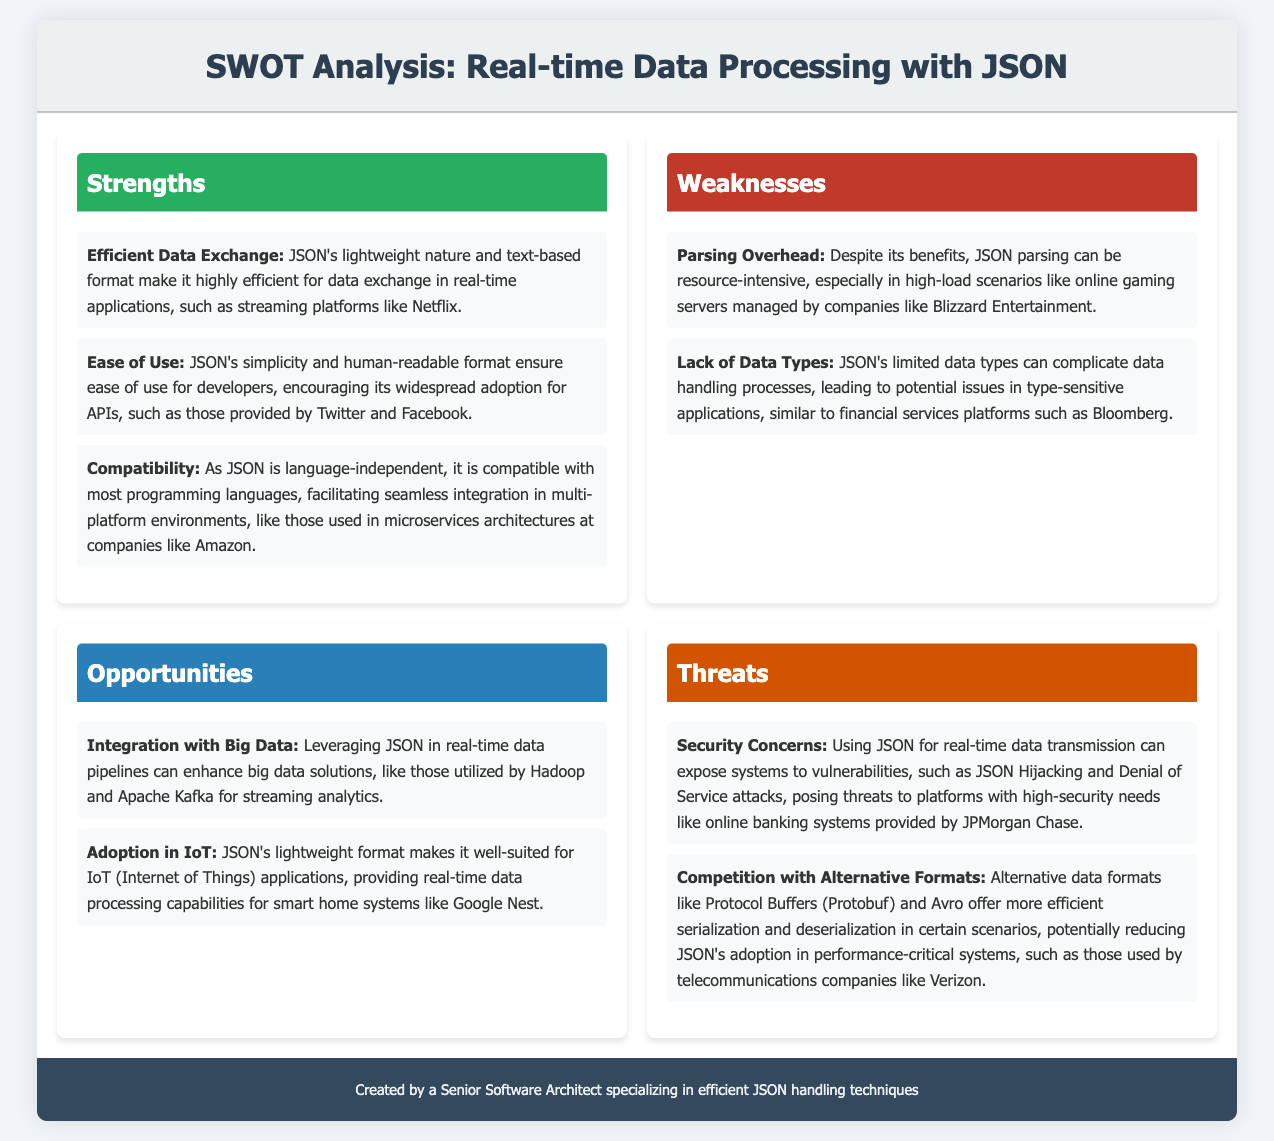what is the title of the document? The title of the document is displayed prominently at the top of the rendered page.
Answer: SWOT Analysis: Real-time Data Processing with JSON how many strengths are listed in the document? The document lists three strengths under the strengths section.
Answer: 3 what is one example of a company that benefits from JSON's lightweight nature? The document provides Netflix as an example of a company that benefits from JSON's lightweight nature.
Answer: Netflix what are two weaknesses associated with JSON mentioned in the document? The document identifies two weaknesses: "Parsing Overhead" and "Lack of Data Types."
Answer: Parsing Overhead, Lack of Data Types which data format is mentioned as an alternative to JSON? The document mentions Protocol Buffers (Protobuf) and Avro as alternatives to JSON.
Answer: Protocol Buffers (Protobuf) what opportunity does the document mention related to IoT? The document states that JSON's lightweight format makes it well-suited for IoT applications.
Answer: JSON's lightweight format what type of applications are highlighted in the opportunities section? The document highlights big data solutions and IoT applications in the opportunities section.
Answer: Big Data, IoT which company is cited as having security needs related to JSON? JPMorgan Chase is cited in the document regarding security needs related to JSON.
Answer: JPMorgan Chase 